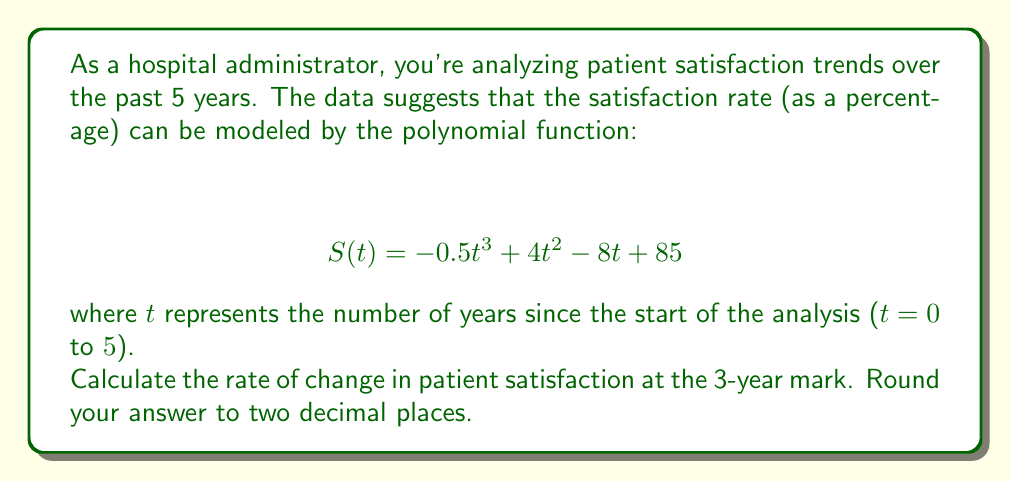Show me your answer to this math problem. To find the rate of change in patient satisfaction at the 3-year mark, we need to calculate the derivative of the given function and evaluate it at t = 3.

1. Start with the original function:
   $$ S(t) = -0.5t^3 + 4t^2 - 8t + 85 $$

2. Calculate the derivative:
   $$ S'(t) = -1.5t^2 + 8t - 8 $$

3. Evaluate the derivative at t = 3:
   $$ S'(3) = -1.5(3)^2 + 8(3) - 8 $$
   $$ = -1.5(9) + 24 - 8 $$
   $$ = -13.5 + 24 - 8 $$
   $$ = 2.5 $$

4. Round to two decimal places:
   2.50

The positive value indicates that patient satisfaction is increasing at the 3-year mark. Specifically, it's increasing at a rate of 2.50 percentage points per year at that time.
Answer: 2.50 percentage points per year 